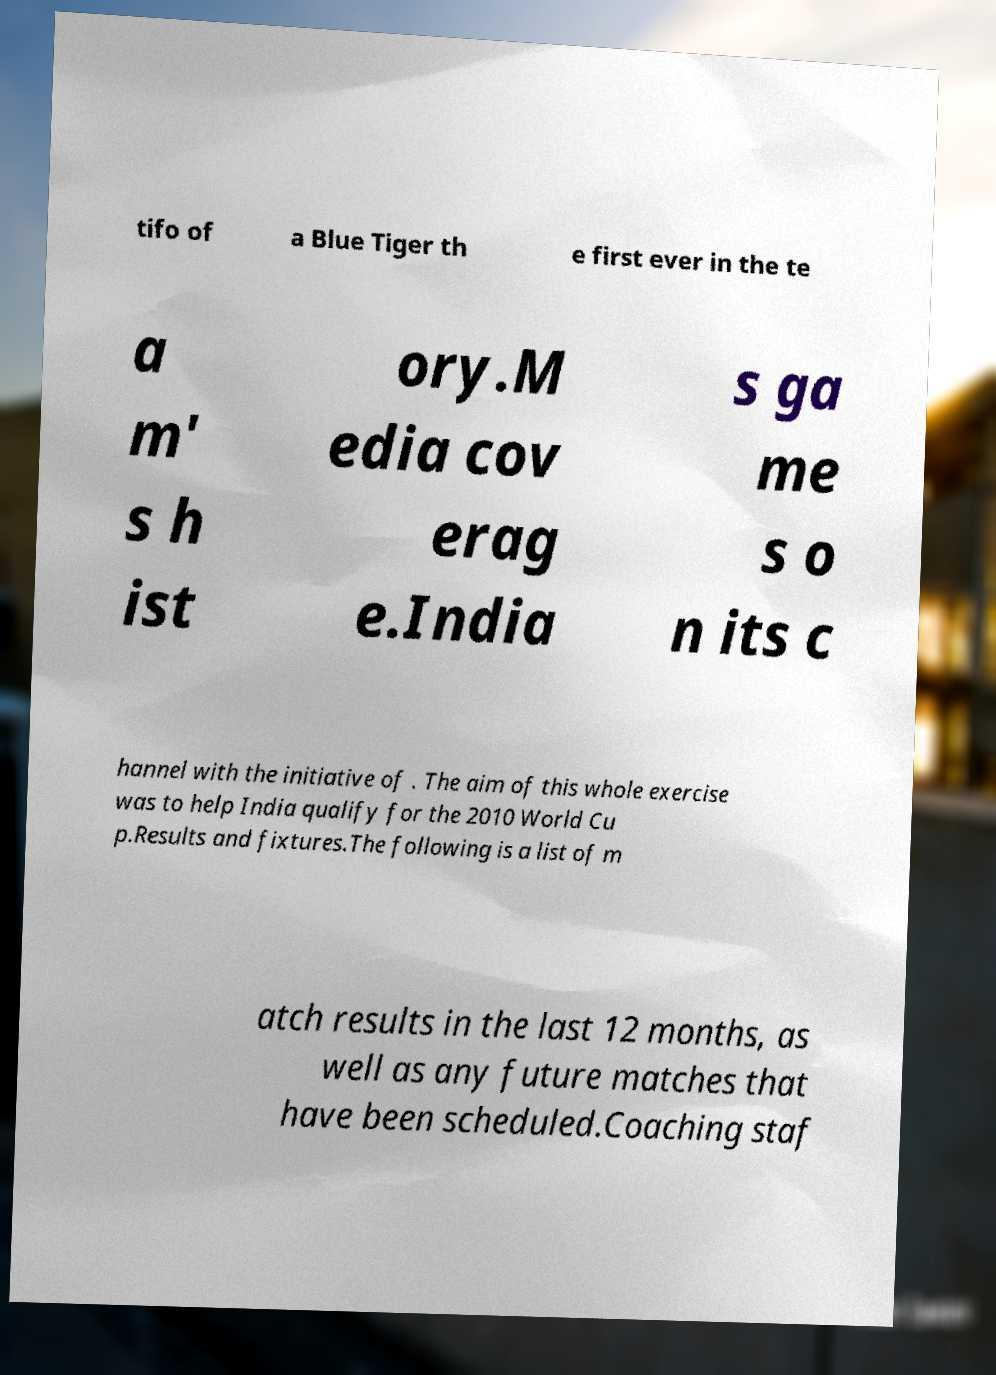There's text embedded in this image that I need extracted. Can you transcribe it verbatim? tifo of a Blue Tiger th e first ever in the te a m' s h ist ory.M edia cov erag e.India s ga me s o n its c hannel with the initiative of . The aim of this whole exercise was to help India qualify for the 2010 World Cu p.Results and fixtures.The following is a list of m atch results in the last 12 months, as well as any future matches that have been scheduled.Coaching staf 